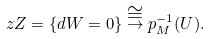<formula> <loc_0><loc_0><loc_500><loc_500>\ z Z = \{ d W = 0 \} \stackrel { \cong } { \to } p _ { M } ^ { - 1 } ( U ) .</formula> 